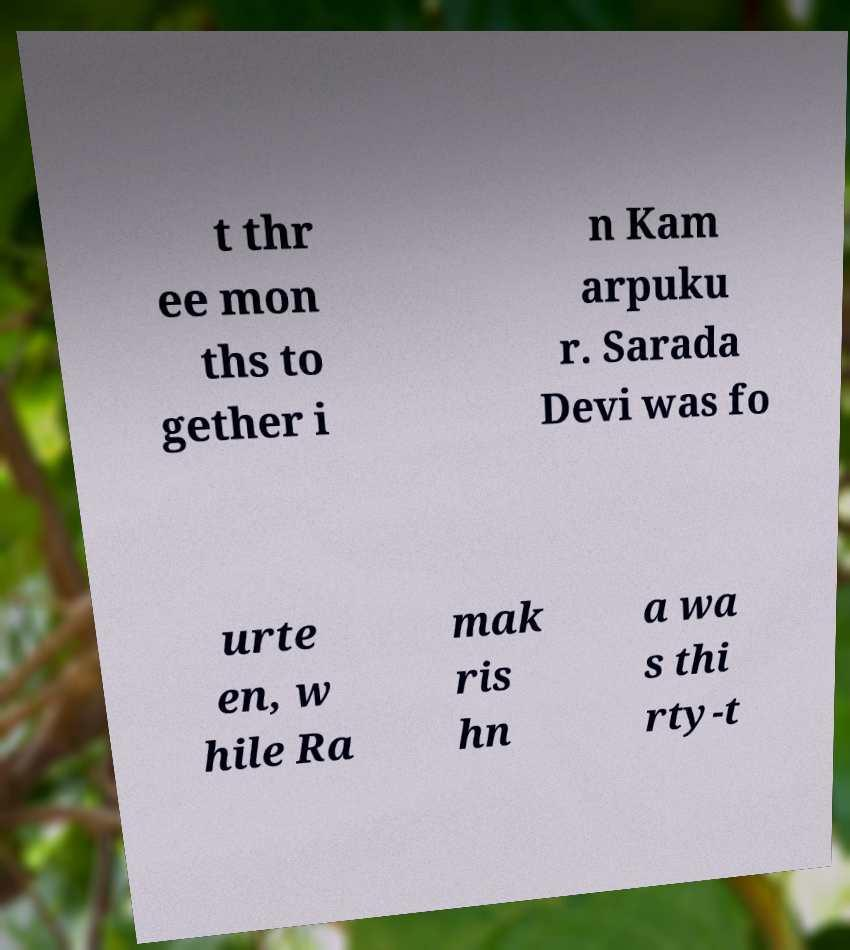For documentation purposes, I need the text within this image transcribed. Could you provide that? t thr ee mon ths to gether i n Kam arpuku r. Sarada Devi was fo urte en, w hile Ra mak ris hn a wa s thi rty-t 